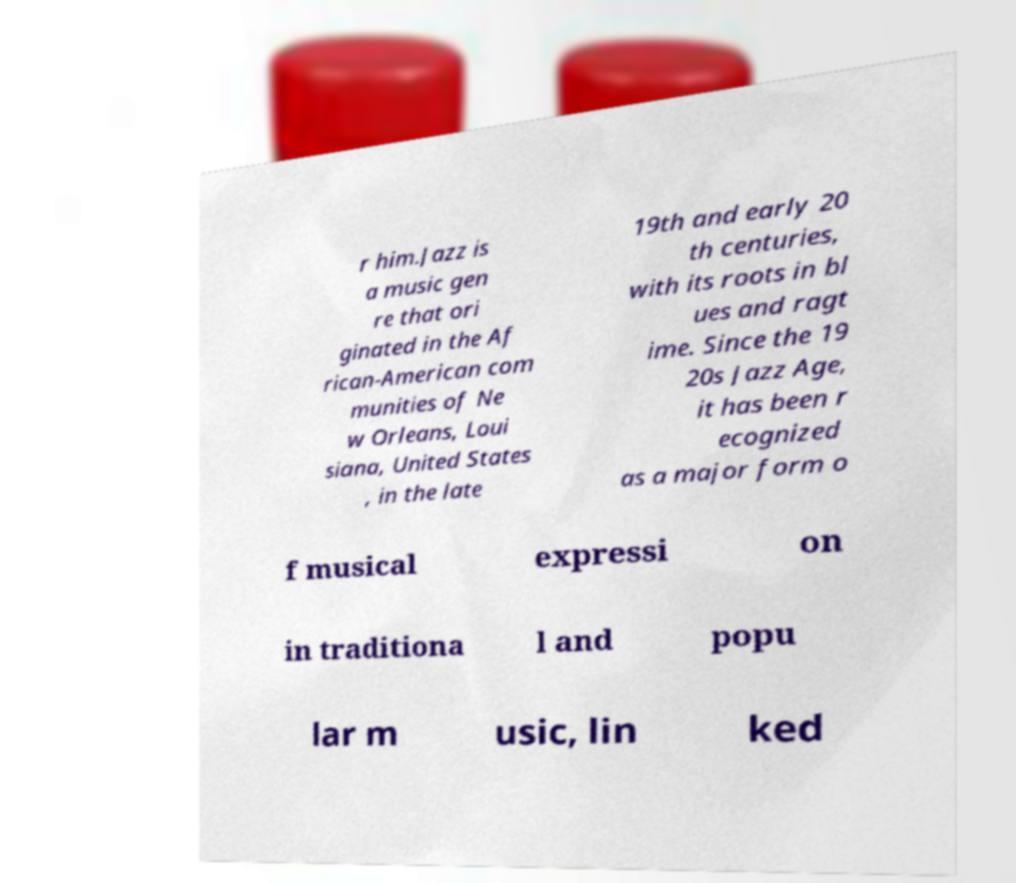Can you read and provide the text displayed in the image?This photo seems to have some interesting text. Can you extract and type it out for me? r him.Jazz is a music gen re that ori ginated in the Af rican-American com munities of Ne w Orleans, Loui siana, United States , in the late 19th and early 20 th centuries, with its roots in bl ues and ragt ime. Since the 19 20s Jazz Age, it has been r ecognized as a major form o f musical expressi on in traditiona l and popu lar m usic, lin ked 